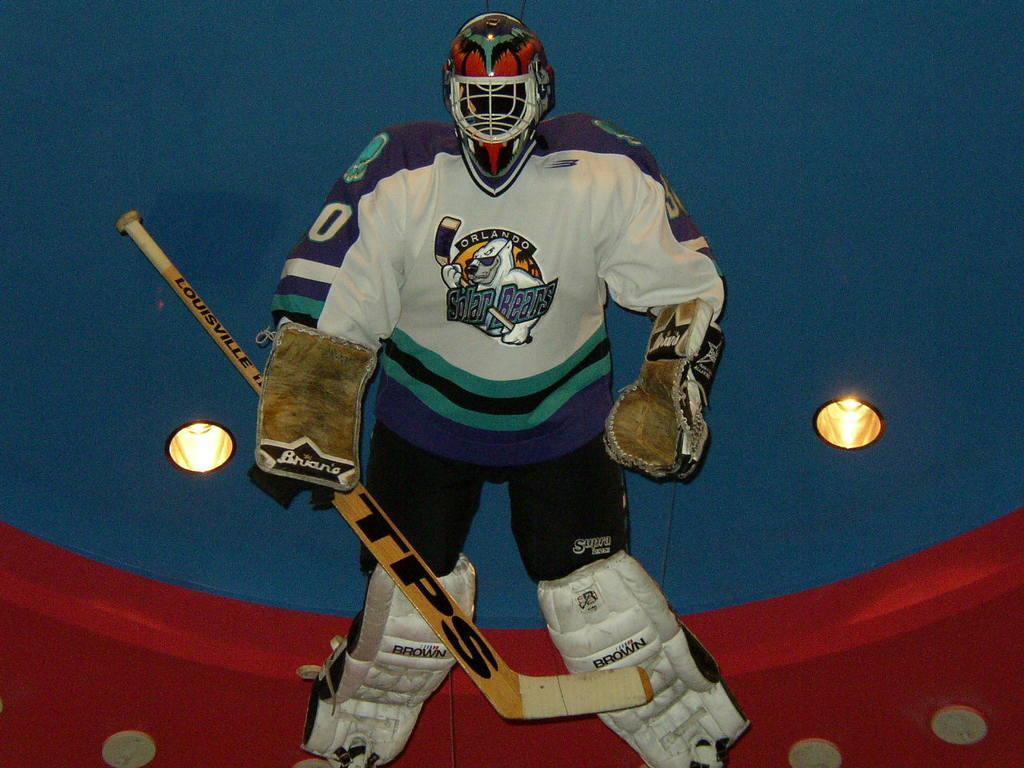Describe this image in one or two sentences. This picture shows a hockey game suit. I see gloves, Helmet and pads to legs and a hockey bat and couple of lights to the ceiling. 